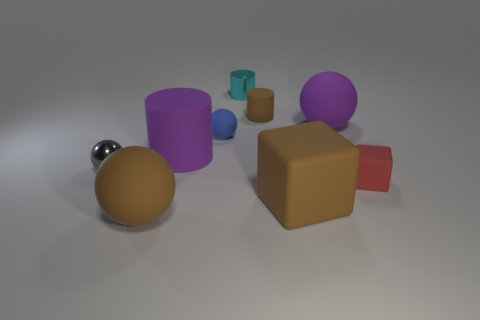There is a tiny metal object in front of the shiny object behind the metallic sphere; are there any brown objects that are in front of it? While there is a small metal object in front of the reflective surface behind the metallic sphere, there are no brown objects positioned in front of the tiny metal object. Rather, the brown objects in the scene, which include a brown cube, are situated behind it from this perspective. 